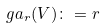Convert formula to latex. <formula><loc_0><loc_0><loc_500><loc_500>\ g a _ { r } ( V ) \colon = r</formula> 